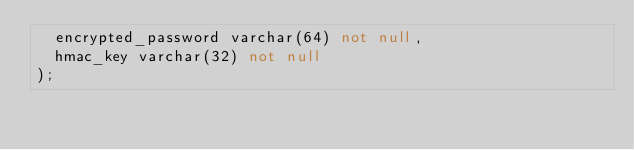<code> <loc_0><loc_0><loc_500><loc_500><_SQL_>	encrypted_password varchar(64) not null,
	hmac_key varchar(32) not null
);
</code> 